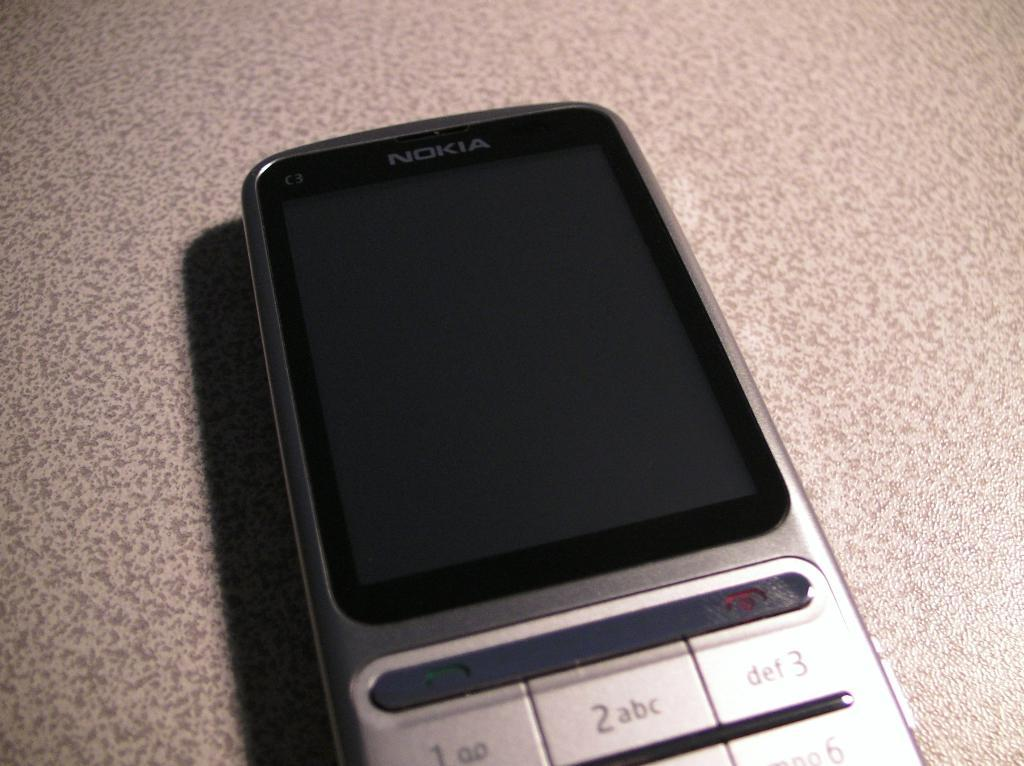Provide a one-sentence caption for the provided image. An old phone by Nokia sits with the screen off. 